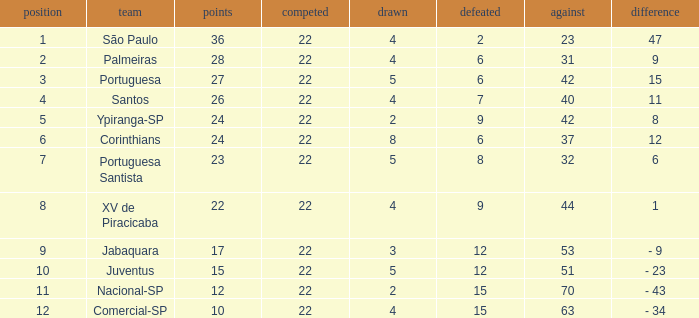Which Against has a Drawn smaller than 5, and a Lost smaller than 6, and a Points larger than 36? 0.0. 